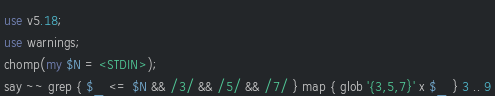<code> <loc_0><loc_0><loc_500><loc_500><_Perl_>use v5.18;
use warnings;
chomp(my $N = <STDIN>);
say ~~ grep { $_ <= $N && /3/ && /5/ && /7/ } map { glob '{3,5,7}' x $_ } 3 .. 9</code> 